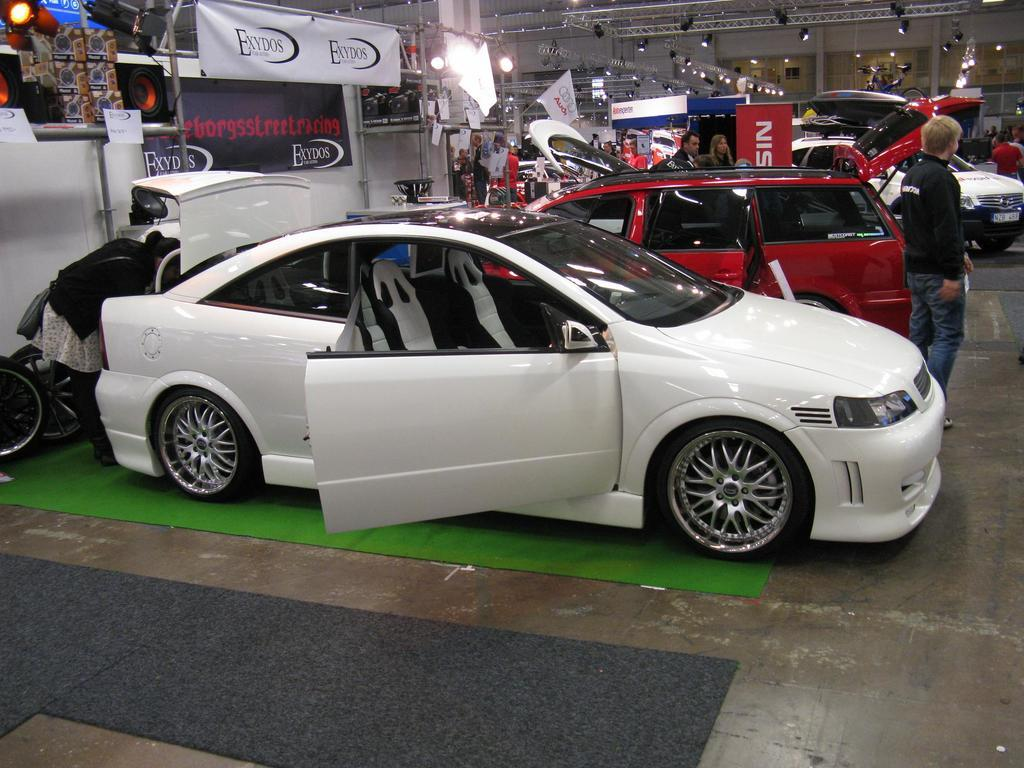What object is located on the floor in the image? There is a vehicle visible on the floor. Who or what is in front of the floor? There is a person standing in front of the floor. What is above the floor in the image? The top of the image includes a roof. What type of natural elements can be seen at the top of the image? Trees are visible at the top of the image. What type of country is depicted in the image? There is no country depicted in the image; it features a vehicle, a person, a roof, and trees. Can you tell me how many goldfish are swimming in the vehicle? There are no goldfish present in the image; it features a vehicle, a person, a roof, and trees. 